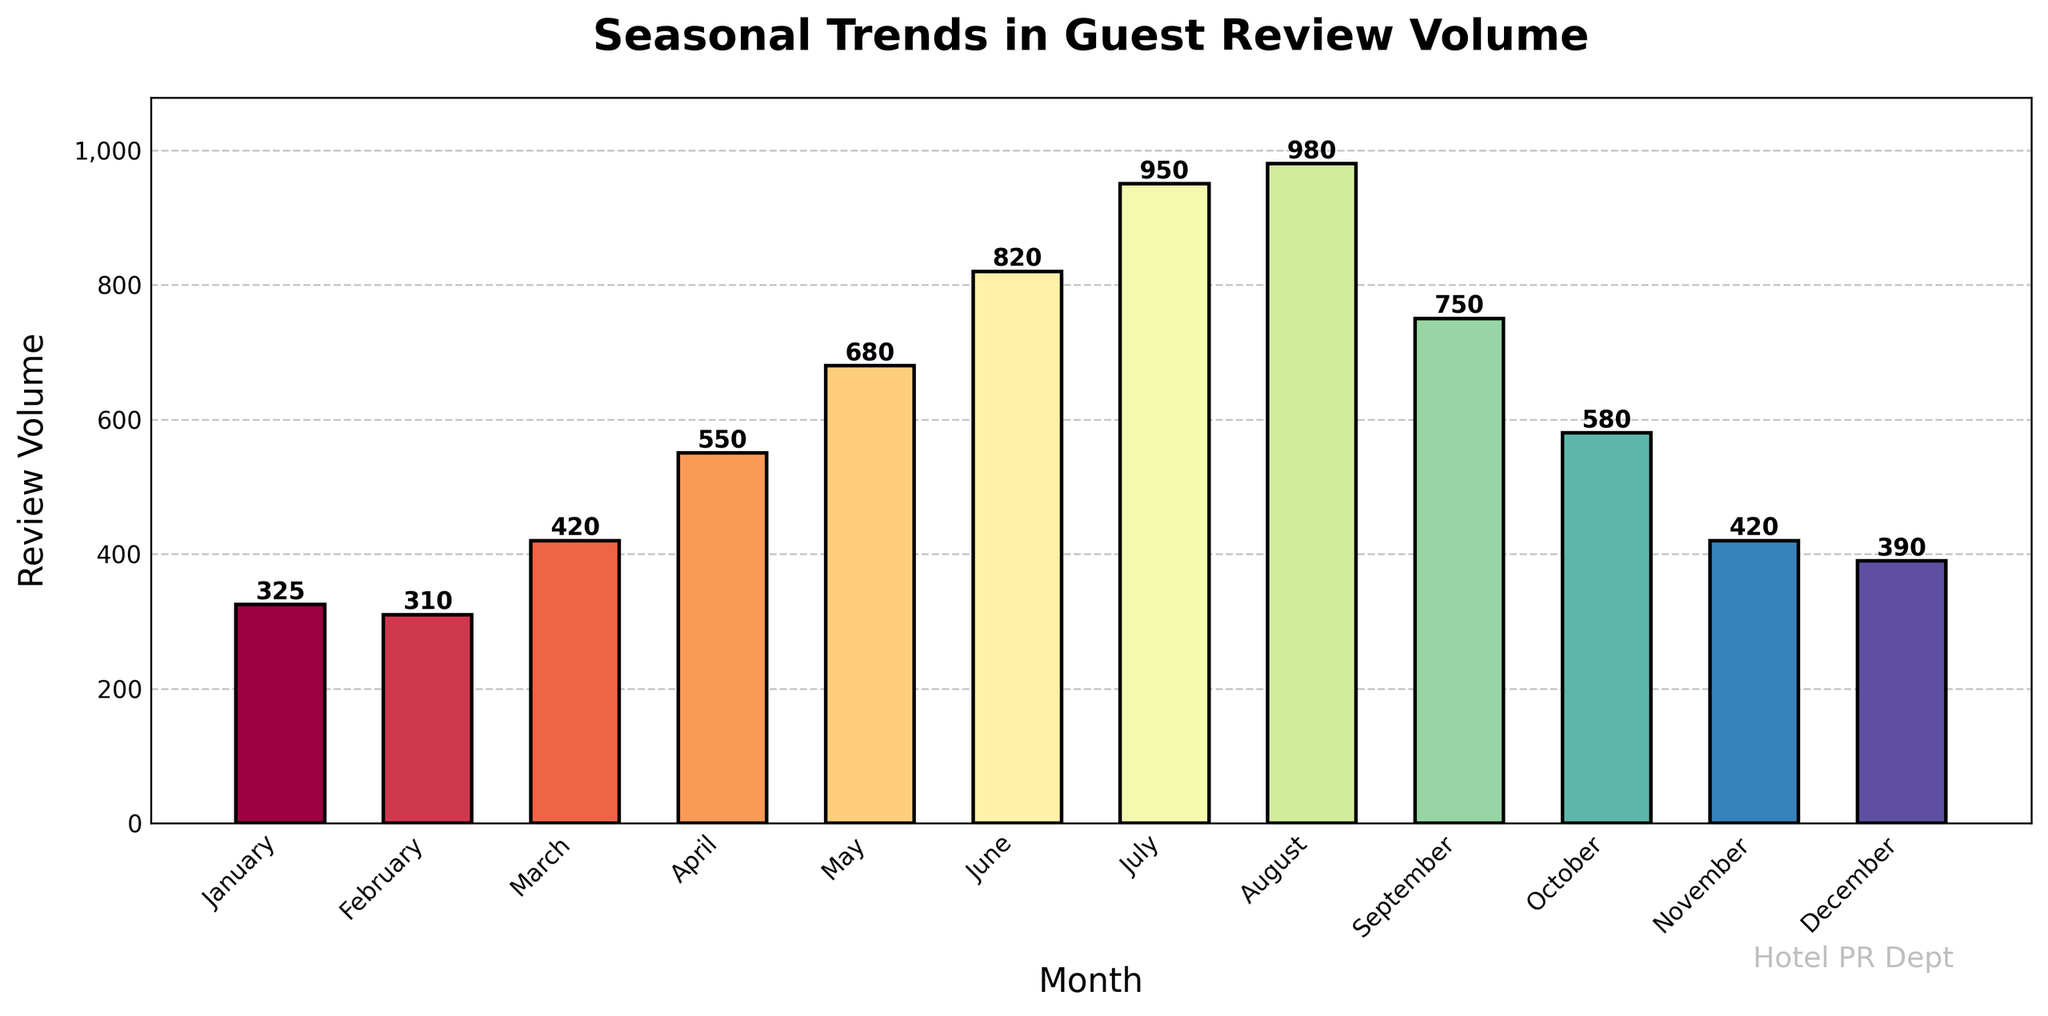How does the review volume in July compare to that in January? We look at the review volumes for July and January from the chart. July has 950 reviews, and January has 325 reviews. July's review volume is higher.
Answer: July has more reviews than January What is the difference in review volume between the month with the highest reviews and the month with the lowest reviews? The month with the highest reviews is August with 980 reviews. The month with the lowest reviews is February with 310 reviews. The difference is calculated as 980 - 310.
Answer: 670 Which month experiences the highest review volume, and what is the review count? By observing the bar heights, we see that August has the highest bar. The review volume for August is 980.
Answer: August, 980 What is the average review volume from January to June? Sum the review volumes from January to June (325 + 310 + 420 + 550 + 680 + 820) and divide by 6. The sum is 3105. The average is 3105 / 6.
Answer: 517.5 In which quarter of the year does the review volume increase the most? Group the months into quarters: Q1 (January-March), Q2 (April-June), Q3 (July-September), Q4 (October-December). Calculate the difference in review volumes for the quarters: Q2 experiences the highest increase (950 - 310 = 640).
Answer: Q2 (April to June) How does September's review volume compare to the previous month, August? Review volumes for August and September are 980 and 750, respectively. Subtract September's review from August's review: 980 - 750.
Answer: September is 230 reviews less than August What is the median review volume across all months? Order the review volumes and find the middle values since there are 12 months: (310, 325, 390, 420, 420, 550, 580, 680, 750, 820, 950, 980). The middle values are 550 and 580. The median is the average of these two.
Answer: 565 By how much does the review volume increase from March to May? Review volumes for March and May are 420 and 680, respectively. Subtract March's volume from May's volume: 680 - 420.
Answer: 260 Which three consecutive months have the highest combined review volume? Examine combined volumes for every set of three consecutive months: June-August has the highest (820 + 950 + 980).
Answer: June-August Identify the months where the review volume is below the annual average review volume. First, calculate the annual average by summing all review volumes and dividing by 12. The total review volume is 7175. The average is 7175 / 12 = 597.92. Identify months with reviews below this value.
Answer: January, February, March, April, November, December 